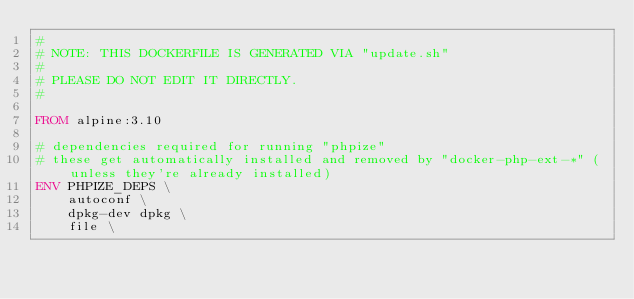Convert code to text. <code><loc_0><loc_0><loc_500><loc_500><_Dockerfile_>#
# NOTE: THIS DOCKERFILE IS GENERATED VIA "update.sh"
#
# PLEASE DO NOT EDIT IT DIRECTLY.
#

FROM alpine:3.10

# dependencies required for running "phpize"
# these get automatically installed and removed by "docker-php-ext-*" (unless they're already installed)
ENV PHPIZE_DEPS \
		autoconf \
		dpkg-dev dpkg \
		file \</code> 